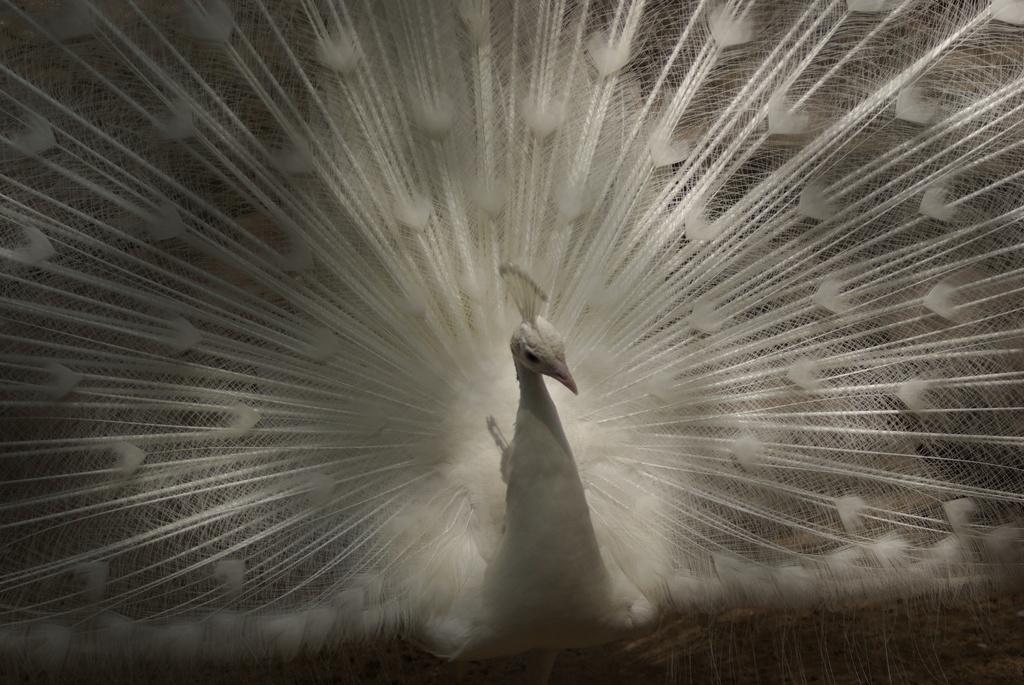How would you summarize this image in a sentence or two? In this picture I can see the white color peacock. In the bottom right corner I can see the floor. 